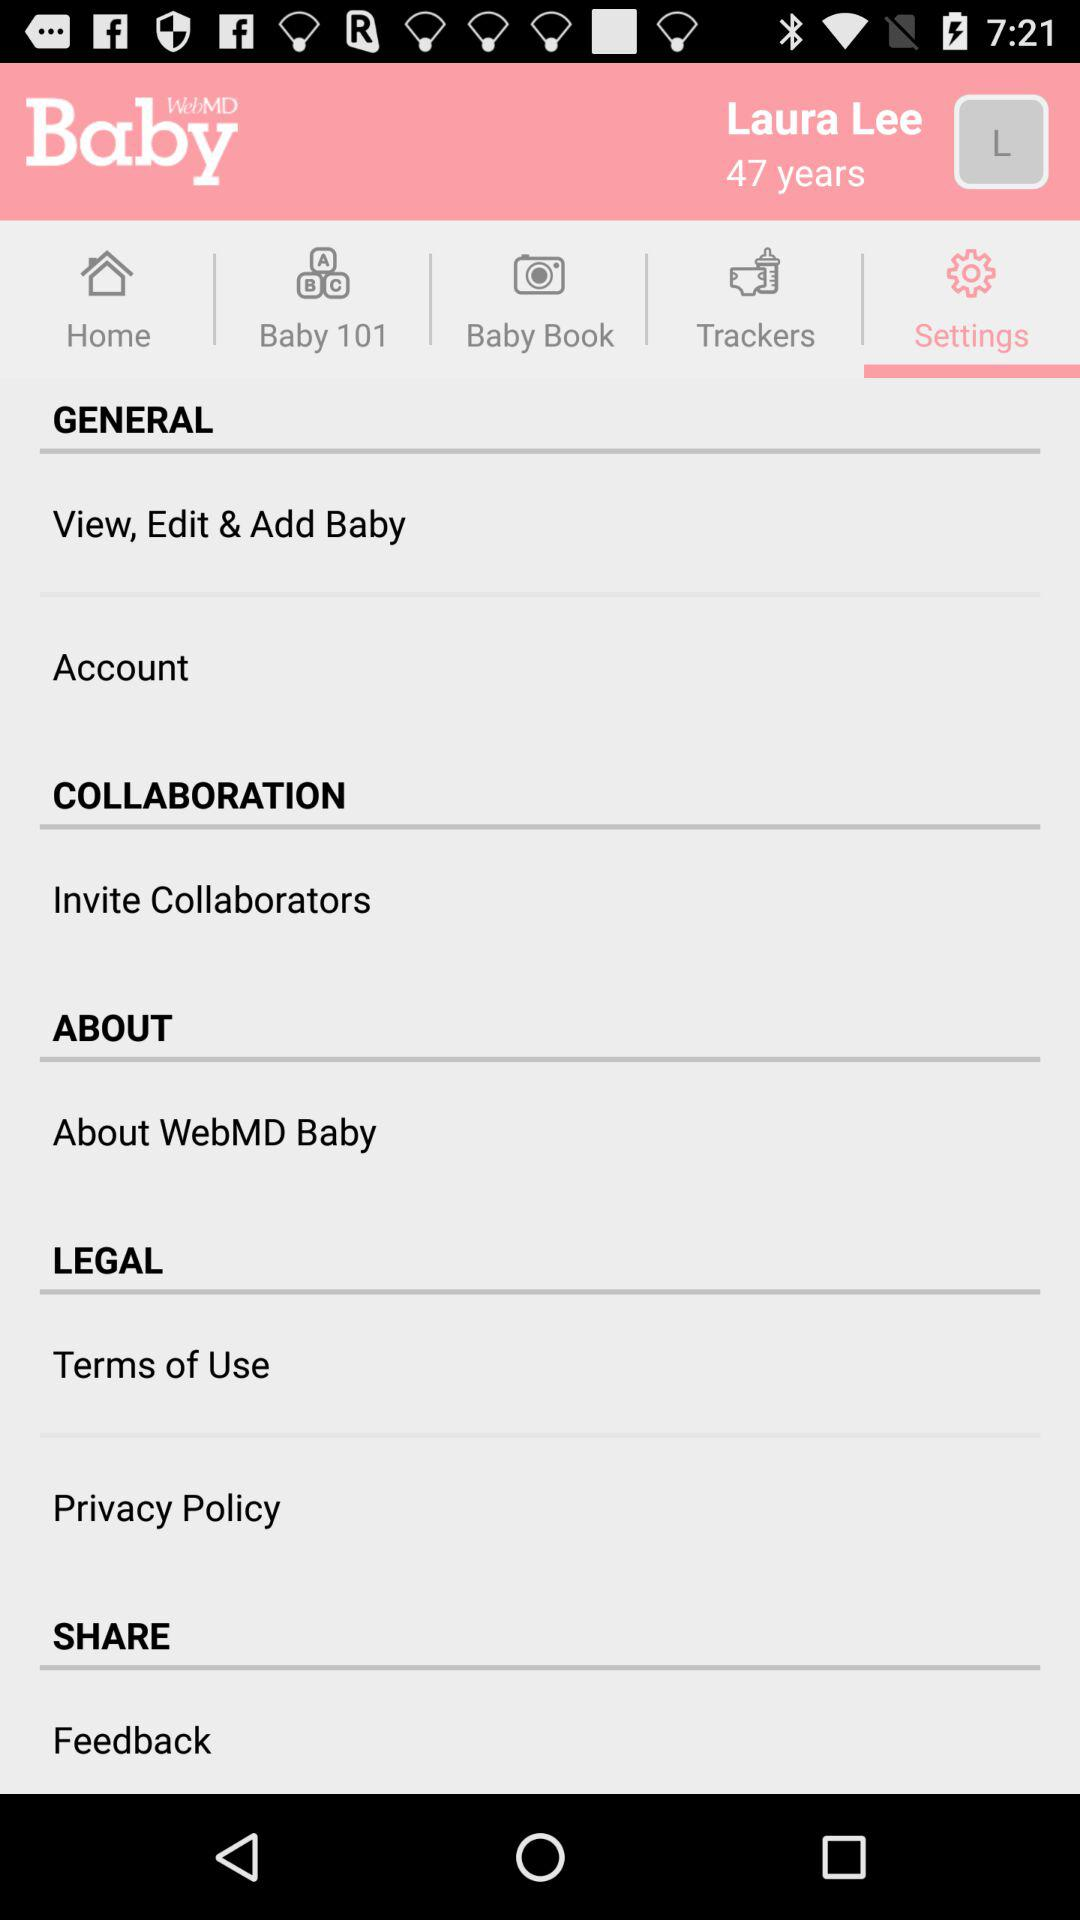What is the age of Laura Lee? The age of Laura Lee is 47 years. 